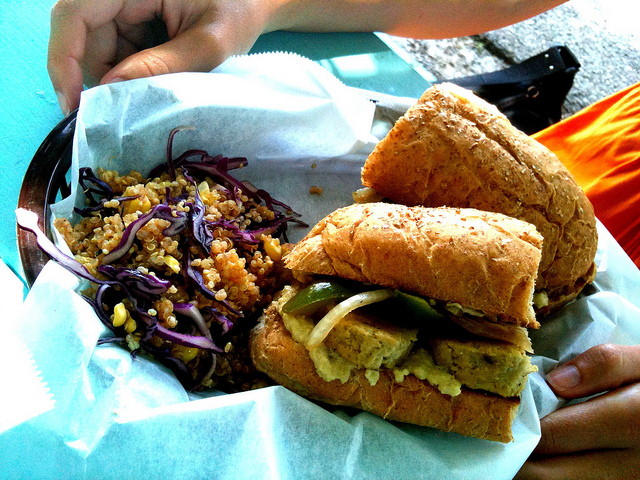What type of food is shown?
A. donuts
B. soup
C. fruit
D. sandwiches The image displays a scrumptious sandwich, likely packed with a variety of fillings such as grilled vegetables and condiments, nestled between two pieces of hearty bread. Accompanying the sandwich, appears to be a side of a grain-based salad, potentially featuring quinoa, garnished with red cabbage, providing a wholesome and balanced meal option. 